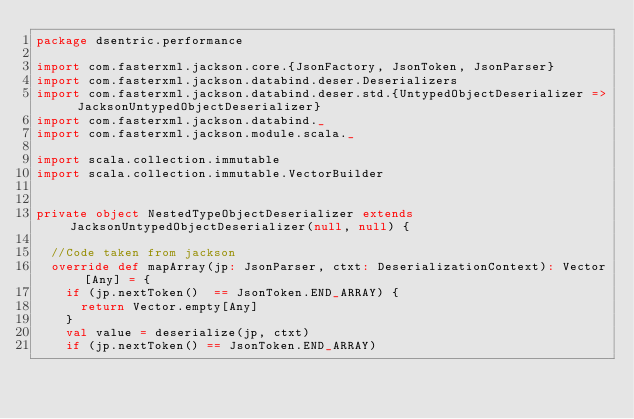<code> <loc_0><loc_0><loc_500><loc_500><_Scala_>package dsentric.performance

import com.fasterxml.jackson.core.{JsonFactory, JsonToken, JsonParser}
import com.fasterxml.jackson.databind.deser.Deserializers
import com.fasterxml.jackson.databind.deser.std.{UntypedObjectDeserializer => JacksonUntypedObjectDeserializer}
import com.fasterxml.jackson.databind._
import com.fasterxml.jackson.module.scala._

import scala.collection.immutable
import scala.collection.immutable.VectorBuilder


private object NestedTypeObjectDeserializer extends JacksonUntypedObjectDeserializer(null, null) {

  //Code taken from jackson
  override def mapArray(jp: JsonParser, ctxt: DeserializationContext): Vector[Any] = {
    if (jp.nextToken()  == JsonToken.END_ARRAY) {
      return Vector.empty[Any]
    }
    val value = deserialize(jp, ctxt)
    if (jp.nextToken() == JsonToken.END_ARRAY)</code> 